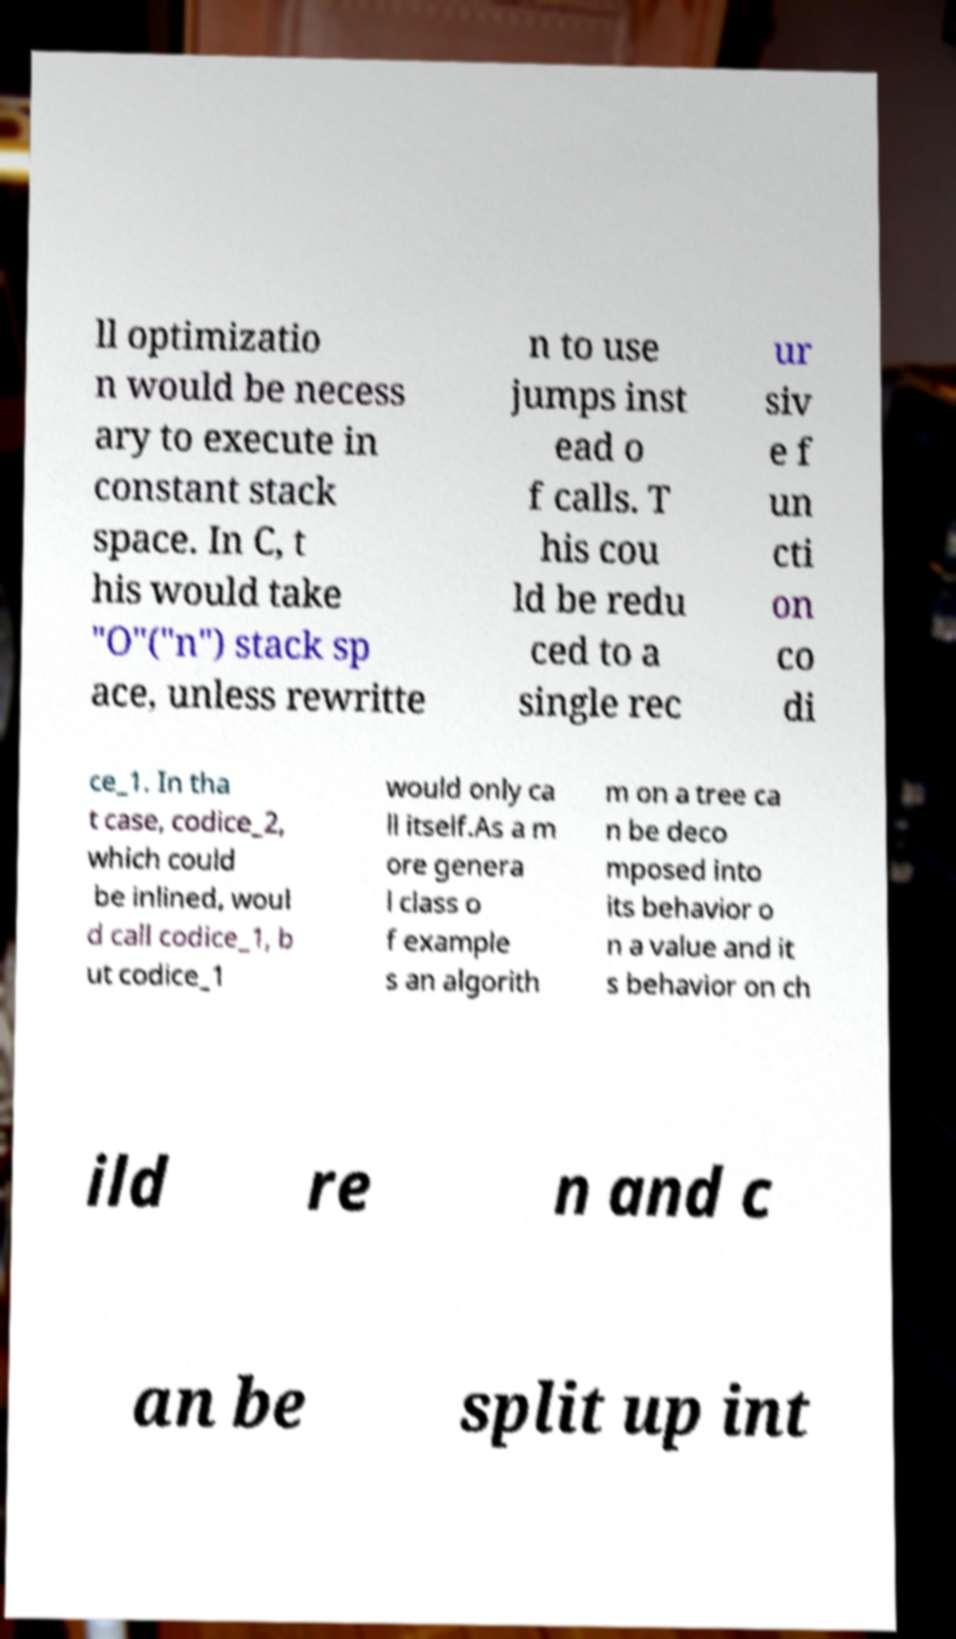Can you accurately transcribe the text from the provided image for me? ll optimizatio n would be necess ary to execute in constant stack space. In C, t his would take "O"("n") stack sp ace, unless rewritte n to use jumps inst ead o f calls. T his cou ld be redu ced to a single rec ur siv e f un cti on co di ce_1. In tha t case, codice_2, which could be inlined, woul d call codice_1, b ut codice_1 would only ca ll itself.As a m ore genera l class o f example s an algorith m on a tree ca n be deco mposed into its behavior o n a value and it s behavior on ch ild re n and c an be split up int 